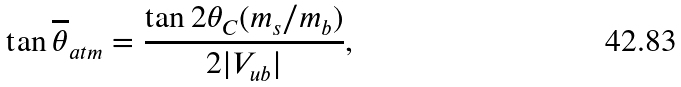<formula> <loc_0><loc_0><loc_500><loc_500>\tan \overline { \theta } _ { a t m } = \frac { \tan 2 \theta _ { C } ( m _ { s } / m _ { b } ) } { 2 | V _ { u b } | } ,</formula> 